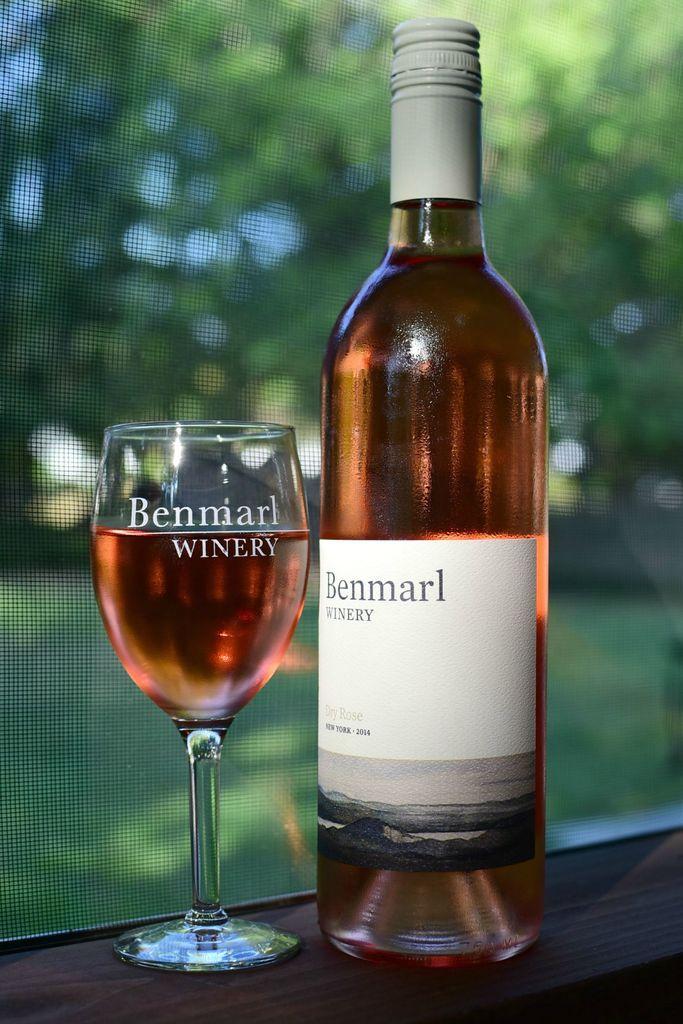Could you give a brief overview of what you see in this image? In this picture we can see bottle with sticker to it and aside to this we have glass with drink in it and this are placed on a table and in background we can see tree, grass. 